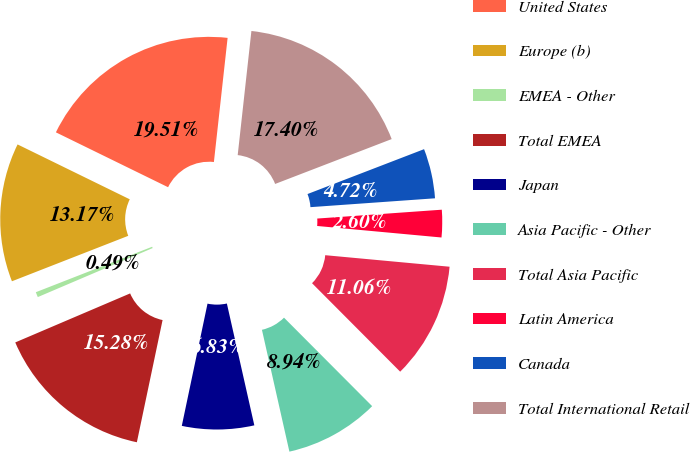Convert chart. <chart><loc_0><loc_0><loc_500><loc_500><pie_chart><fcel>United States<fcel>Europe (b)<fcel>EMEA - Other<fcel>Total EMEA<fcel>Japan<fcel>Asia Pacific - Other<fcel>Total Asia Pacific<fcel>Latin America<fcel>Canada<fcel>Total International Retail<nl><fcel>19.51%<fcel>13.17%<fcel>0.49%<fcel>15.28%<fcel>6.83%<fcel>8.94%<fcel>11.06%<fcel>2.6%<fcel>4.72%<fcel>17.4%<nl></chart> 